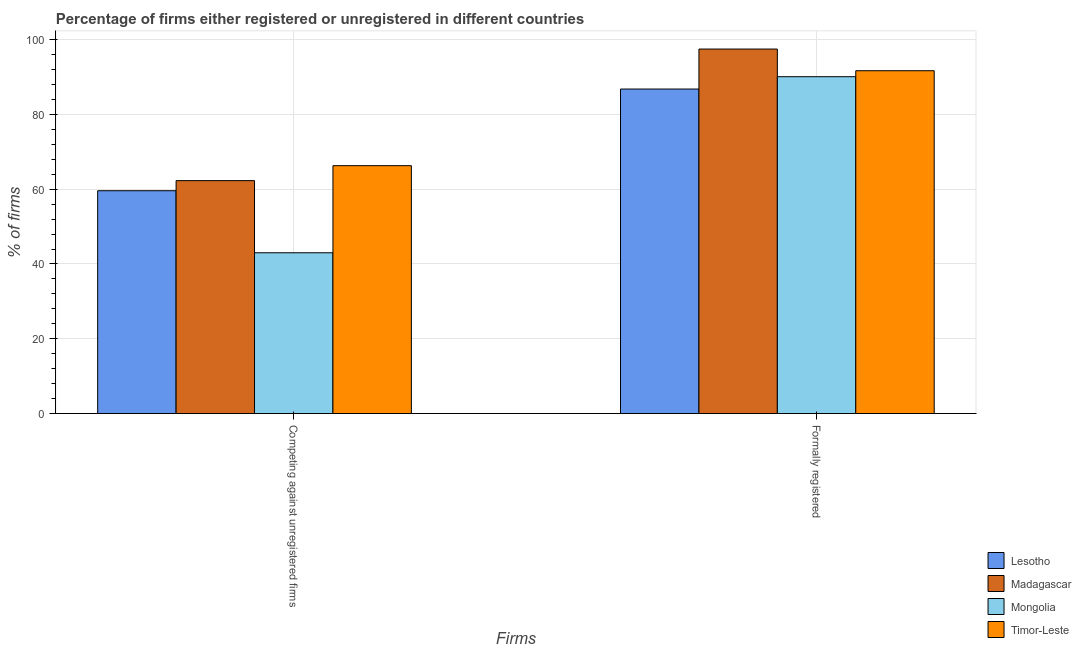Are the number of bars per tick equal to the number of legend labels?
Offer a very short reply. Yes. How many bars are there on the 1st tick from the left?
Make the answer very short. 4. What is the label of the 1st group of bars from the left?
Offer a very short reply. Competing against unregistered firms. What is the percentage of registered firms in Madagascar?
Ensure brevity in your answer.  62.3. Across all countries, what is the maximum percentage of formally registered firms?
Your answer should be compact. 97.5. Across all countries, what is the minimum percentage of registered firms?
Give a very brief answer. 43. In which country was the percentage of formally registered firms maximum?
Make the answer very short. Madagascar. In which country was the percentage of registered firms minimum?
Provide a succinct answer. Mongolia. What is the total percentage of registered firms in the graph?
Your answer should be compact. 231.2. What is the difference between the percentage of registered firms in Mongolia and that in Timor-Leste?
Provide a succinct answer. -23.3. What is the difference between the percentage of registered firms in Lesotho and the percentage of formally registered firms in Timor-Leste?
Offer a very short reply. -32.1. What is the average percentage of formally registered firms per country?
Give a very brief answer. 91.52. What is the difference between the percentage of registered firms and percentage of formally registered firms in Mongolia?
Your answer should be very brief. -47.1. What is the ratio of the percentage of formally registered firms in Lesotho to that in Madagascar?
Provide a short and direct response. 0.89. Is the percentage of registered firms in Mongolia less than that in Lesotho?
Your answer should be compact. Yes. What does the 4th bar from the left in Competing against unregistered firms represents?
Make the answer very short. Timor-Leste. What does the 3rd bar from the right in Formally registered represents?
Keep it short and to the point. Madagascar. Are all the bars in the graph horizontal?
Offer a very short reply. No. How many countries are there in the graph?
Offer a terse response. 4. Are the values on the major ticks of Y-axis written in scientific E-notation?
Your response must be concise. No. Does the graph contain grids?
Provide a succinct answer. Yes. Where does the legend appear in the graph?
Offer a very short reply. Bottom right. What is the title of the graph?
Provide a short and direct response. Percentage of firms either registered or unregistered in different countries. What is the label or title of the X-axis?
Offer a very short reply. Firms. What is the label or title of the Y-axis?
Your answer should be very brief. % of firms. What is the % of firms of Lesotho in Competing against unregistered firms?
Offer a very short reply. 59.6. What is the % of firms in Madagascar in Competing against unregistered firms?
Make the answer very short. 62.3. What is the % of firms in Timor-Leste in Competing against unregistered firms?
Provide a succinct answer. 66.3. What is the % of firms of Lesotho in Formally registered?
Keep it short and to the point. 86.8. What is the % of firms in Madagascar in Formally registered?
Provide a succinct answer. 97.5. What is the % of firms of Mongolia in Formally registered?
Your answer should be compact. 90.1. What is the % of firms of Timor-Leste in Formally registered?
Keep it short and to the point. 91.7. Across all Firms, what is the maximum % of firms in Lesotho?
Offer a terse response. 86.8. Across all Firms, what is the maximum % of firms of Madagascar?
Provide a succinct answer. 97.5. Across all Firms, what is the maximum % of firms in Mongolia?
Ensure brevity in your answer.  90.1. Across all Firms, what is the maximum % of firms of Timor-Leste?
Give a very brief answer. 91.7. Across all Firms, what is the minimum % of firms in Lesotho?
Give a very brief answer. 59.6. Across all Firms, what is the minimum % of firms in Madagascar?
Offer a very short reply. 62.3. Across all Firms, what is the minimum % of firms in Mongolia?
Your answer should be very brief. 43. Across all Firms, what is the minimum % of firms of Timor-Leste?
Your answer should be compact. 66.3. What is the total % of firms in Lesotho in the graph?
Provide a succinct answer. 146.4. What is the total % of firms of Madagascar in the graph?
Give a very brief answer. 159.8. What is the total % of firms of Mongolia in the graph?
Make the answer very short. 133.1. What is the total % of firms in Timor-Leste in the graph?
Your response must be concise. 158. What is the difference between the % of firms in Lesotho in Competing against unregistered firms and that in Formally registered?
Your answer should be compact. -27.2. What is the difference between the % of firms in Madagascar in Competing against unregistered firms and that in Formally registered?
Your answer should be compact. -35.2. What is the difference between the % of firms in Mongolia in Competing against unregistered firms and that in Formally registered?
Offer a terse response. -47.1. What is the difference between the % of firms of Timor-Leste in Competing against unregistered firms and that in Formally registered?
Ensure brevity in your answer.  -25.4. What is the difference between the % of firms in Lesotho in Competing against unregistered firms and the % of firms in Madagascar in Formally registered?
Give a very brief answer. -37.9. What is the difference between the % of firms in Lesotho in Competing against unregistered firms and the % of firms in Mongolia in Formally registered?
Provide a succinct answer. -30.5. What is the difference between the % of firms in Lesotho in Competing against unregistered firms and the % of firms in Timor-Leste in Formally registered?
Provide a succinct answer. -32.1. What is the difference between the % of firms in Madagascar in Competing against unregistered firms and the % of firms in Mongolia in Formally registered?
Offer a terse response. -27.8. What is the difference between the % of firms of Madagascar in Competing against unregistered firms and the % of firms of Timor-Leste in Formally registered?
Ensure brevity in your answer.  -29.4. What is the difference between the % of firms in Mongolia in Competing against unregistered firms and the % of firms in Timor-Leste in Formally registered?
Give a very brief answer. -48.7. What is the average % of firms of Lesotho per Firms?
Ensure brevity in your answer.  73.2. What is the average % of firms of Madagascar per Firms?
Keep it short and to the point. 79.9. What is the average % of firms of Mongolia per Firms?
Provide a short and direct response. 66.55. What is the average % of firms in Timor-Leste per Firms?
Offer a very short reply. 79. What is the difference between the % of firms of Lesotho and % of firms of Mongolia in Competing against unregistered firms?
Provide a short and direct response. 16.6. What is the difference between the % of firms of Lesotho and % of firms of Timor-Leste in Competing against unregistered firms?
Offer a terse response. -6.7. What is the difference between the % of firms of Madagascar and % of firms of Mongolia in Competing against unregistered firms?
Offer a very short reply. 19.3. What is the difference between the % of firms of Mongolia and % of firms of Timor-Leste in Competing against unregistered firms?
Your answer should be compact. -23.3. What is the difference between the % of firms in Lesotho and % of firms in Madagascar in Formally registered?
Ensure brevity in your answer.  -10.7. What is the difference between the % of firms in Mongolia and % of firms in Timor-Leste in Formally registered?
Your response must be concise. -1.6. What is the ratio of the % of firms of Lesotho in Competing against unregistered firms to that in Formally registered?
Offer a terse response. 0.69. What is the ratio of the % of firms of Madagascar in Competing against unregistered firms to that in Formally registered?
Offer a very short reply. 0.64. What is the ratio of the % of firms of Mongolia in Competing against unregistered firms to that in Formally registered?
Give a very brief answer. 0.48. What is the ratio of the % of firms of Timor-Leste in Competing against unregistered firms to that in Formally registered?
Make the answer very short. 0.72. What is the difference between the highest and the second highest % of firms of Lesotho?
Provide a short and direct response. 27.2. What is the difference between the highest and the second highest % of firms of Madagascar?
Offer a terse response. 35.2. What is the difference between the highest and the second highest % of firms of Mongolia?
Make the answer very short. 47.1. What is the difference between the highest and the second highest % of firms in Timor-Leste?
Keep it short and to the point. 25.4. What is the difference between the highest and the lowest % of firms of Lesotho?
Provide a short and direct response. 27.2. What is the difference between the highest and the lowest % of firms in Madagascar?
Your answer should be compact. 35.2. What is the difference between the highest and the lowest % of firms in Mongolia?
Make the answer very short. 47.1. What is the difference between the highest and the lowest % of firms in Timor-Leste?
Ensure brevity in your answer.  25.4. 